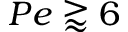<formula> <loc_0><loc_0><loc_500><loc_500>P e \gtrapprox 6</formula> 